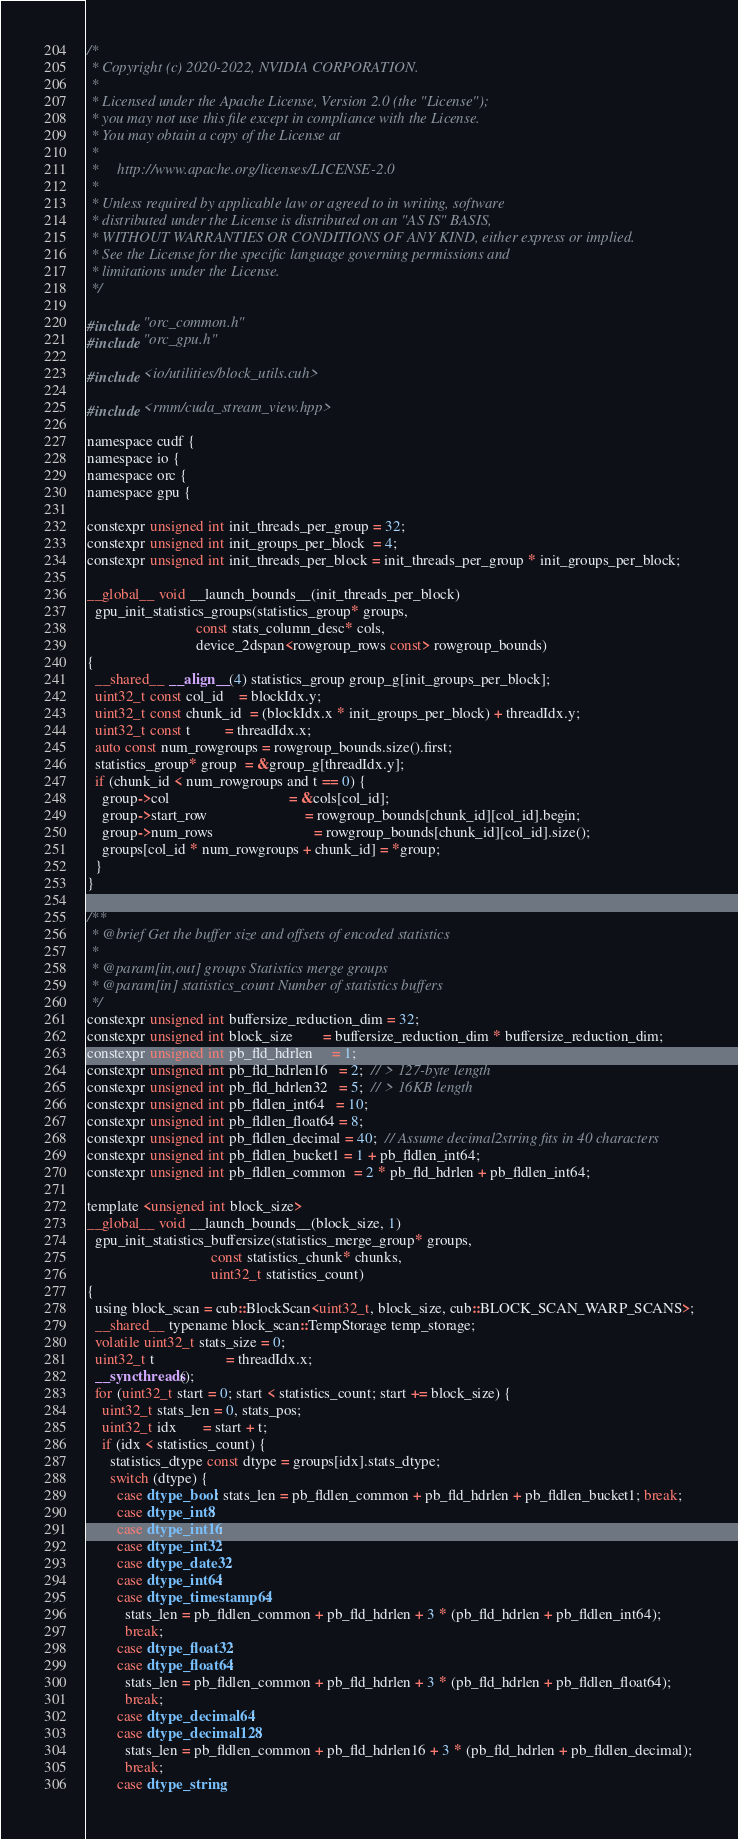Convert code to text. <code><loc_0><loc_0><loc_500><loc_500><_Cuda_>/*
 * Copyright (c) 2020-2022, NVIDIA CORPORATION.
 *
 * Licensed under the Apache License, Version 2.0 (the "License");
 * you may not use this file except in compliance with the License.
 * You may obtain a copy of the License at
 *
 *     http://www.apache.org/licenses/LICENSE-2.0
 *
 * Unless required by applicable law or agreed to in writing, software
 * distributed under the License is distributed on an "AS IS" BASIS,
 * WITHOUT WARRANTIES OR CONDITIONS OF ANY KIND, either express or implied.
 * See the License for the specific language governing permissions and
 * limitations under the License.
 */

#include "orc_common.h"
#include "orc_gpu.h"

#include <io/utilities/block_utils.cuh>

#include <rmm/cuda_stream_view.hpp>

namespace cudf {
namespace io {
namespace orc {
namespace gpu {

constexpr unsigned int init_threads_per_group = 32;
constexpr unsigned int init_groups_per_block  = 4;
constexpr unsigned int init_threads_per_block = init_threads_per_group * init_groups_per_block;

__global__ void __launch_bounds__(init_threads_per_block)
  gpu_init_statistics_groups(statistics_group* groups,
                             const stats_column_desc* cols,
                             device_2dspan<rowgroup_rows const> rowgroup_bounds)
{
  __shared__ __align__(4) statistics_group group_g[init_groups_per_block];
  uint32_t const col_id    = blockIdx.y;
  uint32_t const chunk_id  = (blockIdx.x * init_groups_per_block) + threadIdx.y;
  uint32_t const t         = threadIdx.x;
  auto const num_rowgroups = rowgroup_bounds.size().first;
  statistics_group* group  = &group_g[threadIdx.y];
  if (chunk_id < num_rowgroups and t == 0) {
    group->col                                = &cols[col_id];
    group->start_row                          = rowgroup_bounds[chunk_id][col_id].begin;
    group->num_rows                           = rowgroup_bounds[chunk_id][col_id].size();
    groups[col_id * num_rowgroups + chunk_id] = *group;
  }
}

/**
 * @brief Get the buffer size and offsets of encoded statistics
 *
 * @param[in,out] groups Statistics merge groups
 * @param[in] statistics_count Number of statistics buffers
 */
constexpr unsigned int buffersize_reduction_dim = 32;
constexpr unsigned int block_size        = buffersize_reduction_dim * buffersize_reduction_dim;
constexpr unsigned int pb_fld_hdrlen     = 1;
constexpr unsigned int pb_fld_hdrlen16   = 2;  // > 127-byte length
constexpr unsigned int pb_fld_hdrlen32   = 5;  // > 16KB length
constexpr unsigned int pb_fldlen_int64   = 10;
constexpr unsigned int pb_fldlen_float64 = 8;
constexpr unsigned int pb_fldlen_decimal = 40;  // Assume decimal2string fits in 40 characters
constexpr unsigned int pb_fldlen_bucket1 = 1 + pb_fldlen_int64;
constexpr unsigned int pb_fldlen_common  = 2 * pb_fld_hdrlen + pb_fldlen_int64;

template <unsigned int block_size>
__global__ void __launch_bounds__(block_size, 1)
  gpu_init_statistics_buffersize(statistics_merge_group* groups,
                                 const statistics_chunk* chunks,
                                 uint32_t statistics_count)
{
  using block_scan = cub::BlockScan<uint32_t, block_size, cub::BLOCK_SCAN_WARP_SCANS>;
  __shared__ typename block_scan::TempStorage temp_storage;
  volatile uint32_t stats_size = 0;
  uint32_t t                   = threadIdx.x;
  __syncthreads();
  for (uint32_t start = 0; start < statistics_count; start += block_size) {
    uint32_t stats_len = 0, stats_pos;
    uint32_t idx       = start + t;
    if (idx < statistics_count) {
      statistics_dtype const dtype = groups[idx].stats_dtype;
      switch (dtype) {
        case dtype_bool: stats_len = pb_fldlen_common + pb_fld_hdrlen + pb_fldlen_bucket1; break;
        case dtype_int8:
        case dtype_int16:
        case dtype_int32:
        case dtype_date32:
        case dtype_int64:
        case dtype_timestamp64:
          stats_len = pb_fldlen_common + pb_fld_hdrlen + 3 * (pb_fld_hdrlen + pb_fldlen_int64);
          break;
        case dtype_float32:
        case dtype_float64:
          stats_len = pb_fldlen_common + pb_fld_hdrlen + 3 * (pb_fld_hdrlen + pb_fldlen_float64);
          break;
        case dtype_decimal64:
        case dtype_decimal128:
          stats_len = pb_fldlen_common + pb_fld_hdrlen16 + 3 * (pb_fld_hdrlen + pb_fldlen_decimal);
          break;
        case dtype_string:</code> 